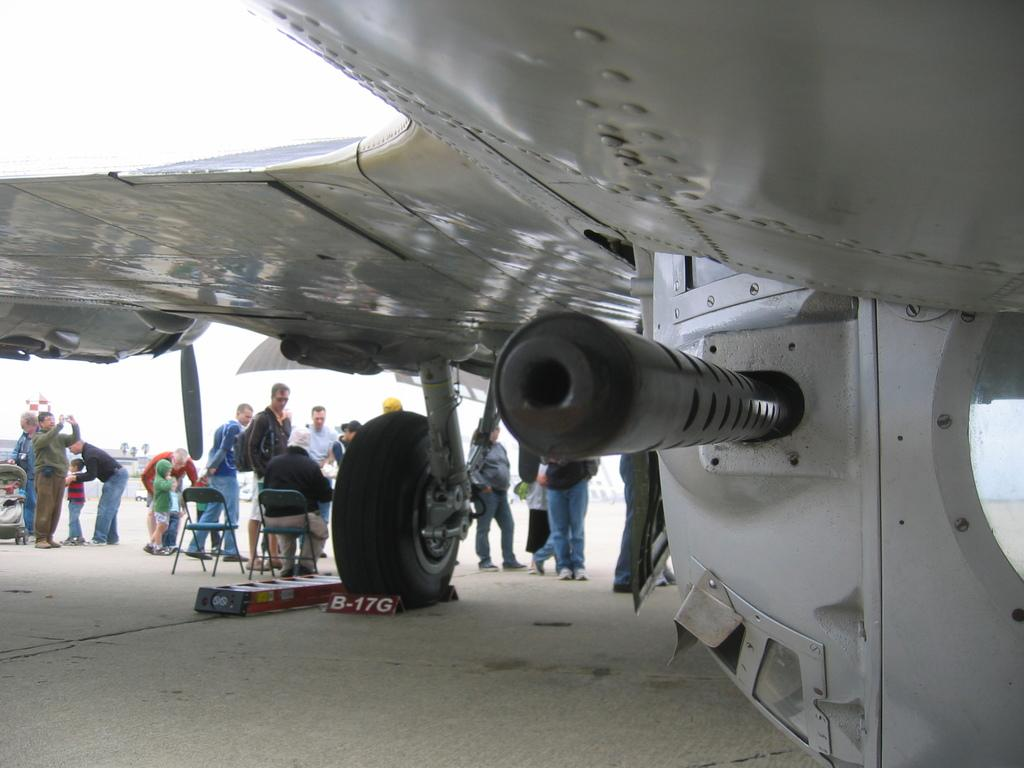<image>
Offer a succinct explanation of the picture presented. A wedge under an airplane wheel has the code B-17G written on it. 